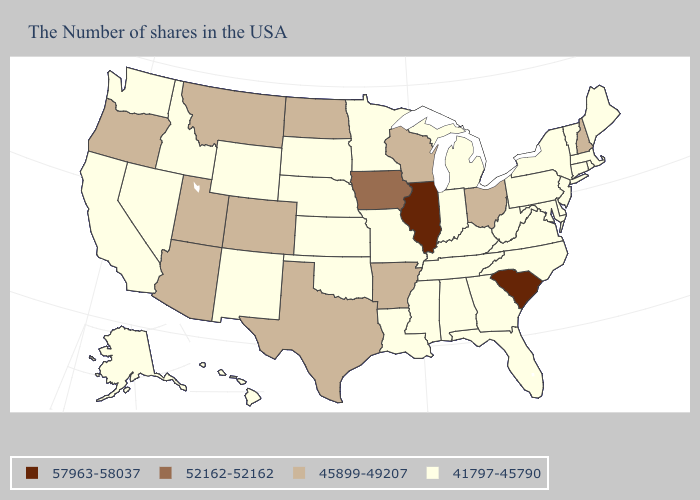Does the map have missing data?
Write a very short answer. No. Among the states that border Montana , which have the highest value?
Concise answer only. North Dakota. Name the states that have a value in the range 57963-58037?
Quick response, please. South Carolina, Illinois. Name the states that have a value in the range 45899-49207?
Short answer required. New Hampshire, Ohio, Wisconsin, Arkansas, Texas, North Dakota, Colorado, Utah, Montana, Arizona, Oregon. What is the value of Wyoming?
Answer briefly. 41797-45790. What is the value of Maine?
Quick response, please. 41797-45790. Name the states that have a value in the range 57963-58037?
Answer briefly. South Carolina, Illinois. Name the states that have a value in the range 41797-45790?
Short answer required. Maine, Massachusetts, Rhode Island, Vermont, Connecticut, New York, New Jersey, Delaware, Maryland, Pennsylvania, Virginia, North Carolina, West Virginia, Florida, Georgia, Michigan, Kentucky, Indiana, Alabama, Tennessee, Mississippi, Louisiana, Missouri, Minnesota, Kansas, Nebraska, Oklahoma, South Dakota, Wyoming, New Mexico, Idaho, Nevada, California, Washington, Alaska, Hawaii. Does Rhode Island have the lowest value in the USA?
Short answer required. Yes. What is the value of Illinois?
Quick response, please. 57963-58037. Does Mississippi have a higher value than Tennessee?
Keep it brief. No. How many symbols are there in the legend?
Answer briefly. 4. What is the highest value in the USA?
Concise answer only. 57963-58037. Which states have the lowest value in the Northeast?
Be succinct. Maine, Massachusetts, Rhode Island, Vermont, Connecticut, New York, New Jersey, Pennsylvania. 